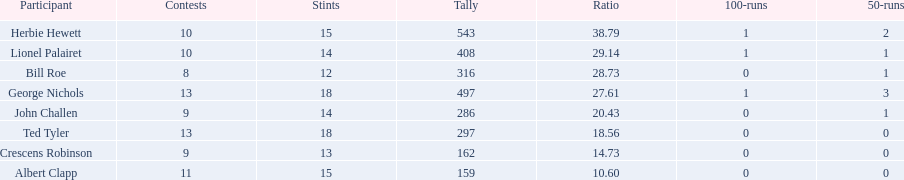What is the least about of runs anyone has? 159. 